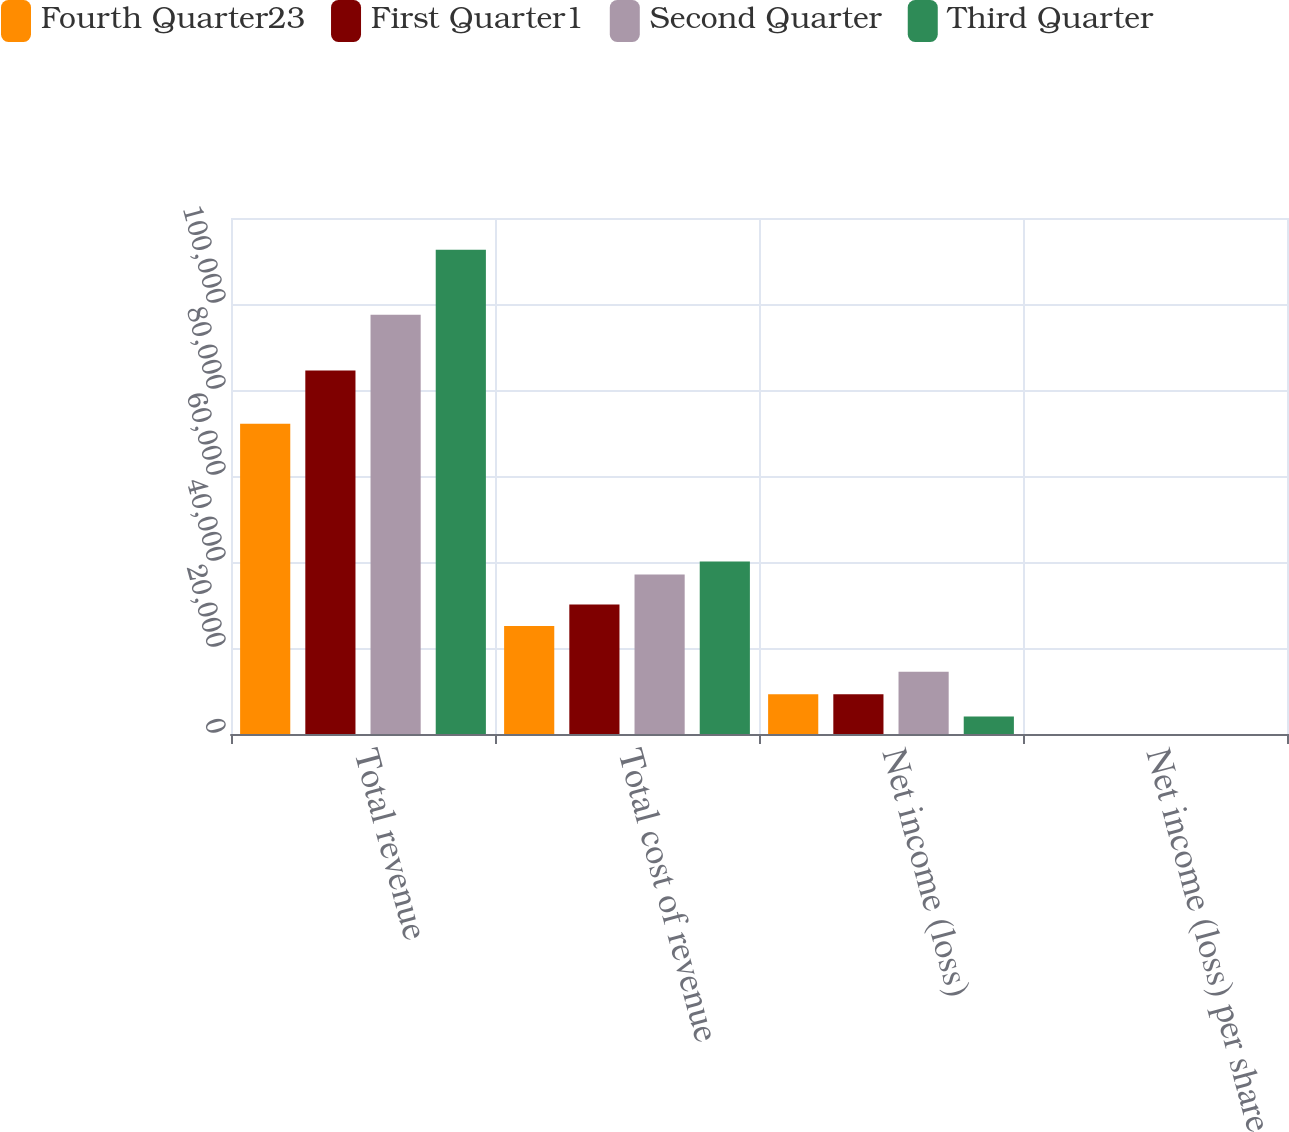<chart> <loc_0><loc_0><loc_500><loc_500><stacked_bar_chart><ecel><fcel>Total revenue<fcel>Total cost of revenue<fcel>Net income (loss)<fcel>Net income (loss) per share<nl><fcel>Fourth Quarter23<fcel>72150<fcel>25120<fcel>9264<fcel>5.58<nl><fcel>First Quarter1<fcel>84535<fcel>30141<fcel>9264<fcel>0.16<nl><fcel>Second Quarter<fcel>97510<fcel>37078<fcel>14503<fcel>0.24<nl><fcel>Third Quarter<fcel>112604<fcel>40097<fcel>4050<fcel>0.07<nl></chart> 